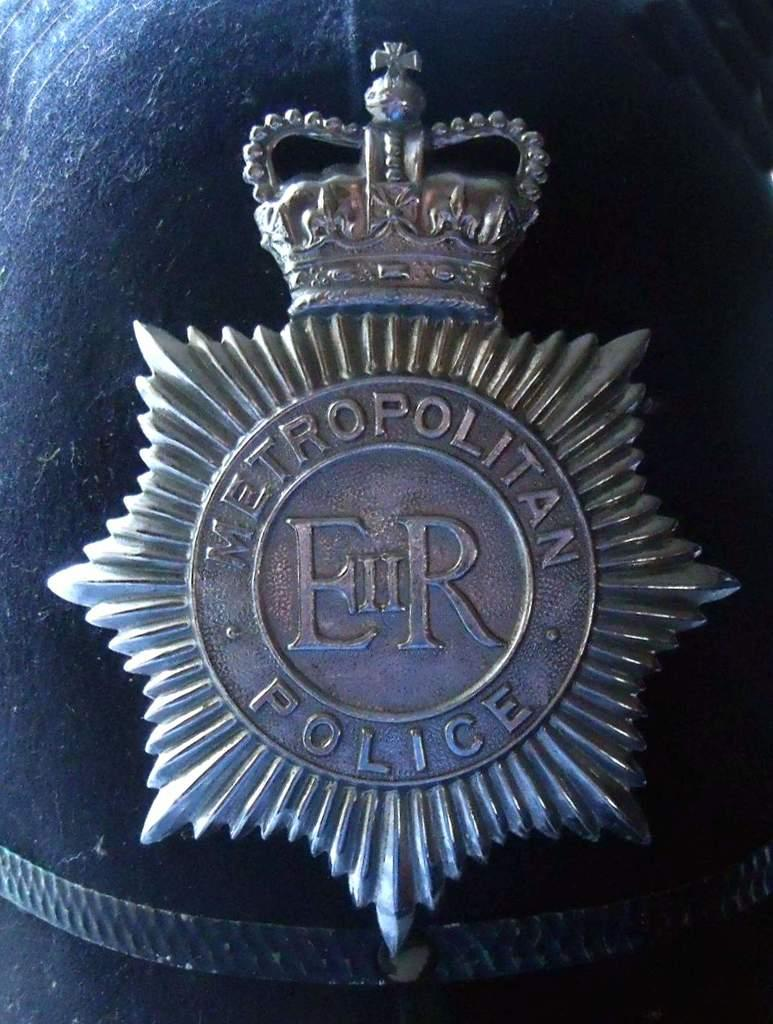<image>
Describe the image concisely. A hat with a badge for the Metropolitan Police. 